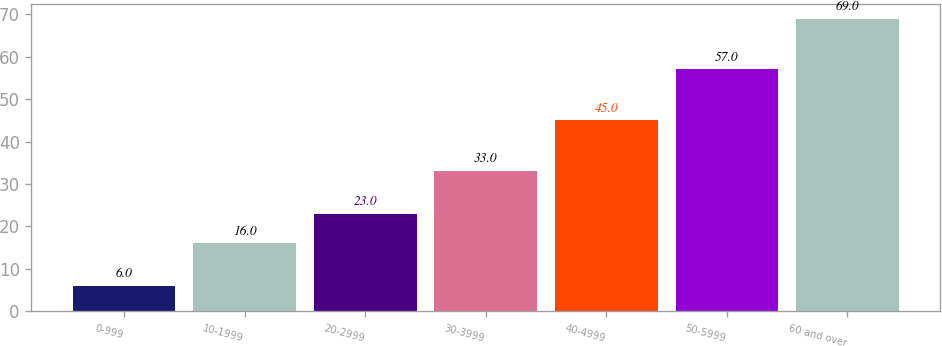Convert chart to OTSL. <chart><loc_0><loc_0><loc_500><loc_500><bar_chart><fcel>0-999<fcel>10-1999<fcel>20-2999<fcel>30-3999<fcel>40-4999<fcel>50-5999<fcel>60 and over<nl><fcel>6<fcel>16<fcel>23<fcel>33<fcel>45<fcel>57<fcel>69<nl></chart> 